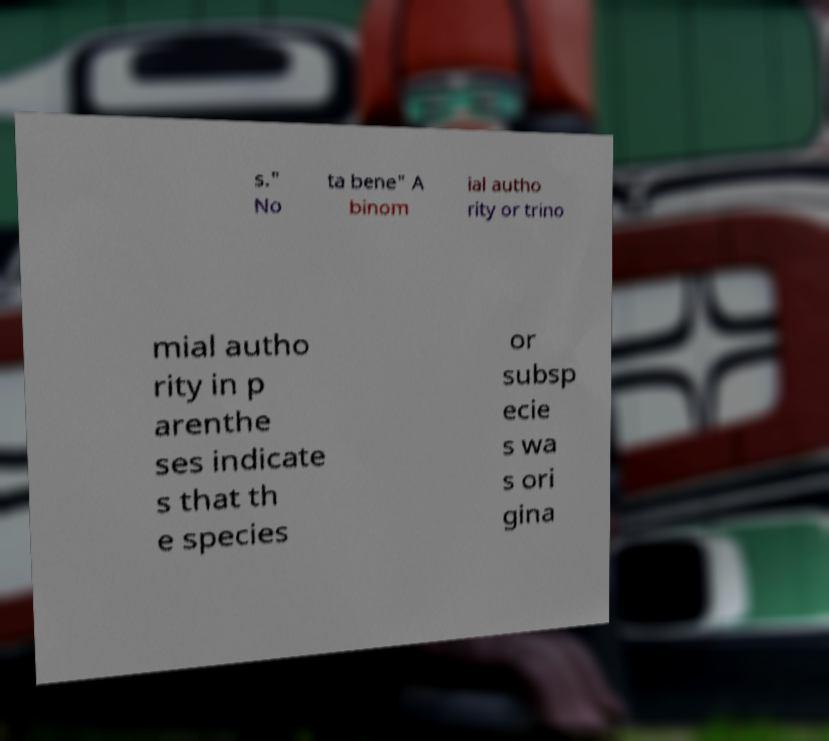For documentation purposes, I need the text within this image transcribed. Could you provide that? s." No ta bene" A binom ial autho rity or trino mial autho rity in p arenthe ses indicate s that th e species or subsp ecie s wa s ori gina 